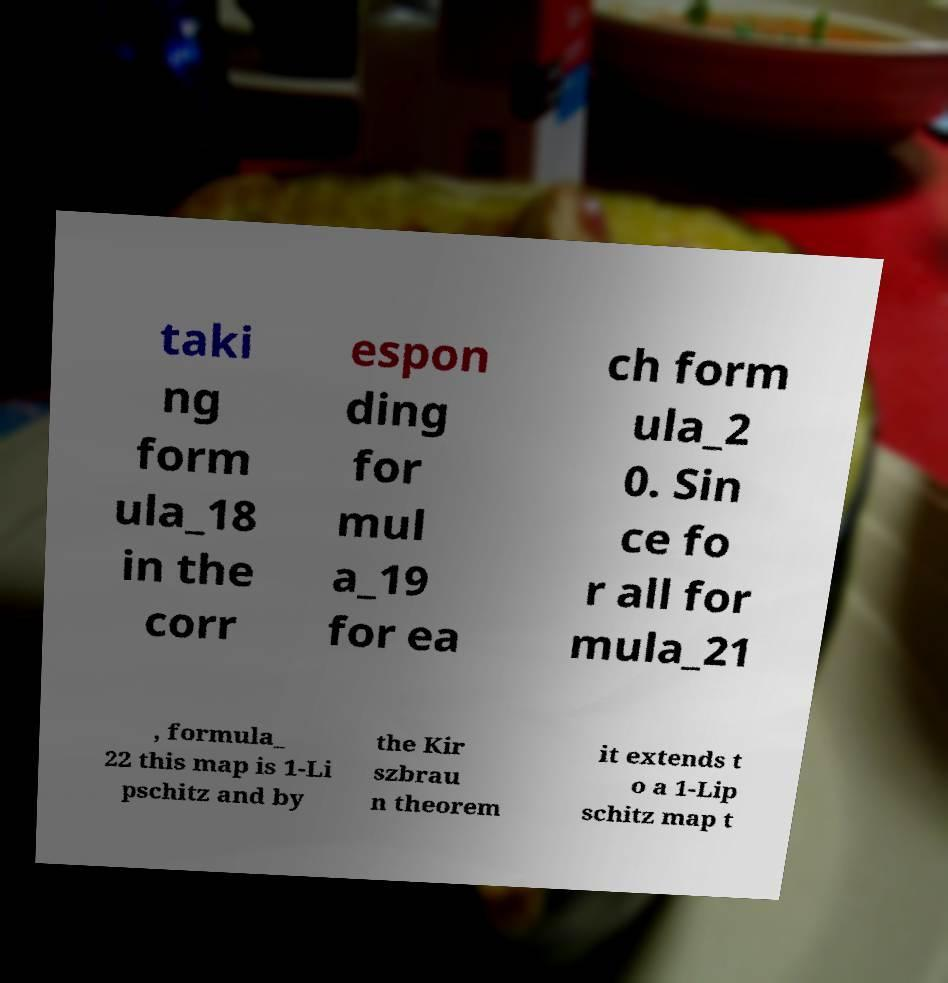Could you assist in decoding the text presented in this image and type it out clearly? taki ng form ula_18 in the corr espon ding for mul a_19 for ea ch form ula_2 0. Sin ce fo r all for mula_21 , formula_ 22 this map is 1-Li pschitz and by the Kir szbrau n theorem it extends t o a 1-Lip schitz map t 